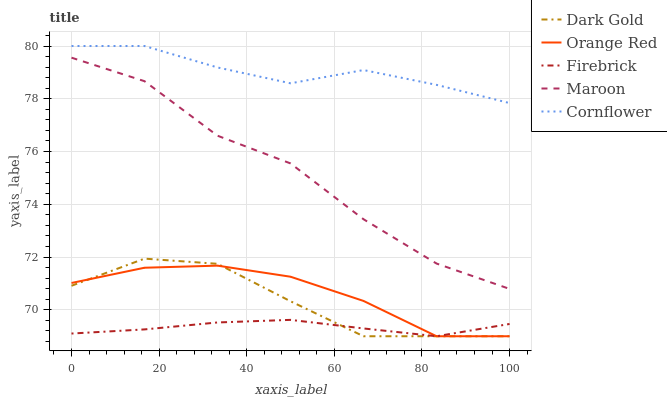Does Orange Red have the minimum area under the curve?
Answer yes or no. No. Does Orange Red have the maximum area under the curve?
Answer yes or no. No. Is Orange Red the smoothest?
Answer yes or no. No. Is Orange Red the roughest?
Answer yes or no. No. Does Maroon have the lowest value?
Answer yes or no. No. Does Orange Red have the highest value?
Answer yes or no. No. Is Firebrick less than Maroon?
Answer yes or no. Yes. Is Maroon greater than Orange Red?
Answer yes or no. Yes. Does Firebrick intersect Maroon?
Answer yes or no. No. 